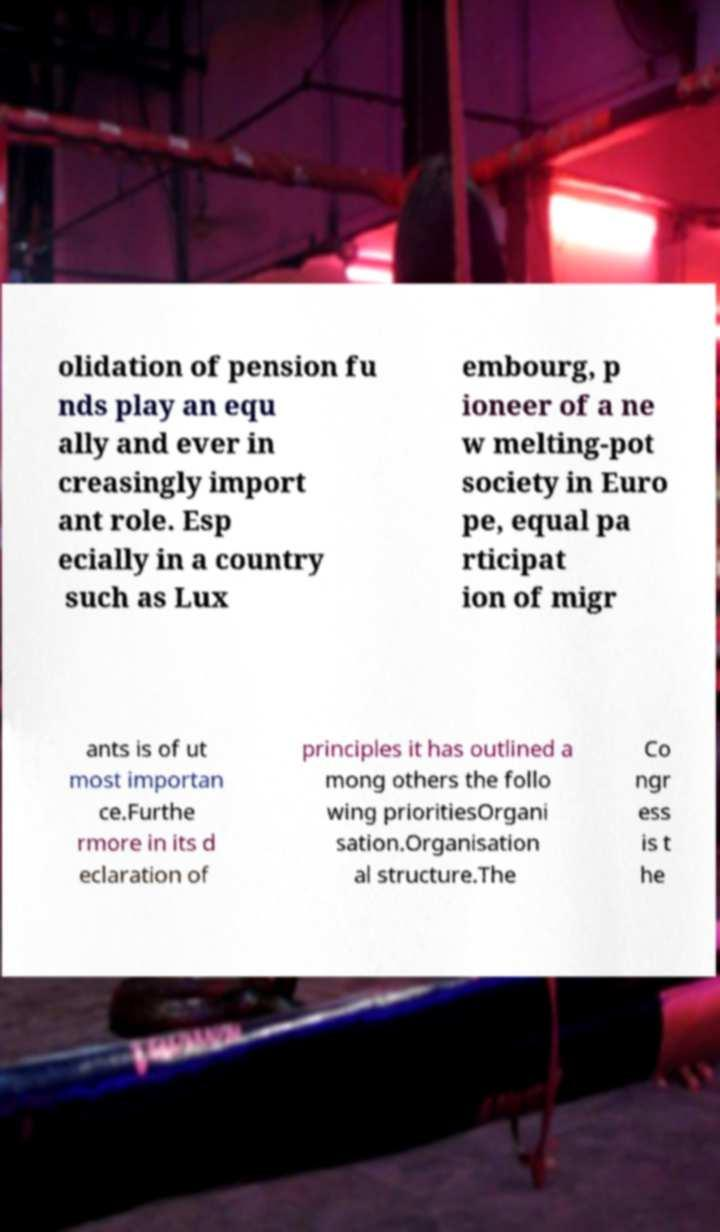What messages or text are displayed in this image? I need them in a readable, typed format. olidation of pension fu nds play an equ ally and ever in creasingly import ant role. Esp ecially in a country such as Lux embourg, p ioneer of a ne w melting-pot society in Euro pe, equal pa rticipat ion of migr ants is of ut most importan ce.Furthe rmore in its d eclaration of principles it has outlined a mong others the follo wing prioritiesOrgani sation.Organisation al structure.The Co ngr ess is t he 